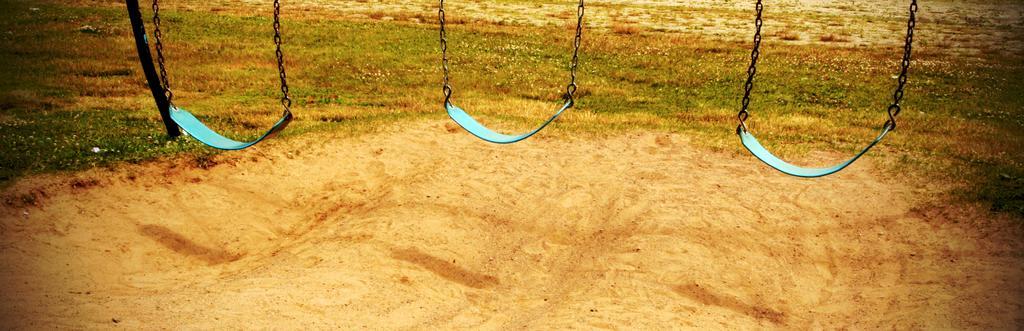Could you give a brief overview of what you see in this image? In this image I can see the swings with metal chains. In the background I can see the pole and the grass. 